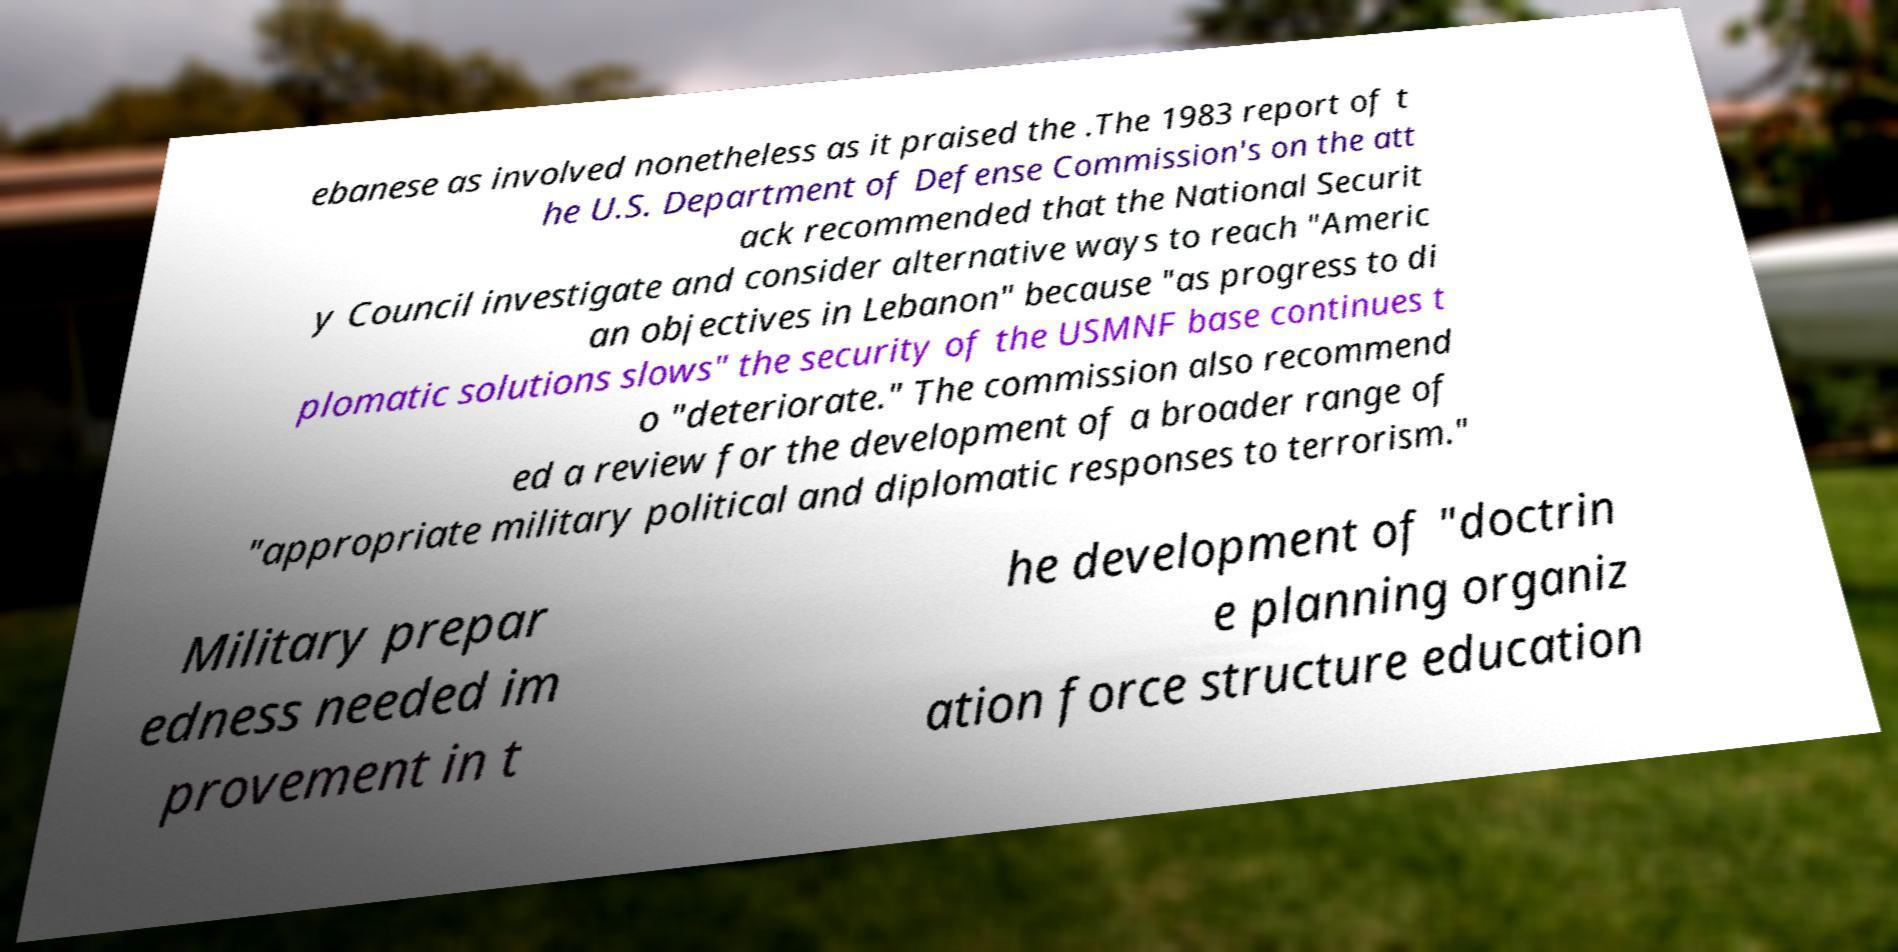Can you accurately transcribe the text from the provided image for me? ebanese as involved nonetheless as it praised the .The 1983 report of t he U.S. Department of Defense Commission's on the att ack recommended that the National Securit y Council investigate and consider alternative ways to reach "Americ an objectives in Lebanon" because "as progress to di plomatic solutions slows" the security of the USMNF base continues t o "deteriorate." The commission also recommend ed a review for the development of a broader range of "appropriate military political and diplomatic responses to terrorism." Military prepar edness needed im provement in t he development of "doctrin e planning organiz ation force structure education 